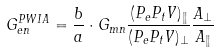Convert formula to latex. <formula><loc_0><loc_0><loc_500><loc_500>G _ { e n } ^ { P W I A } = \frac { b } { a } \cdot G _ { m n } \frac { ( P _ { e } P _ { t } V ) _ { \| } } { ( P _ { e } P _ { t } V ) _ { \perp } } \frac { A _ { \perp } } { A _ { \| } }</formula> 